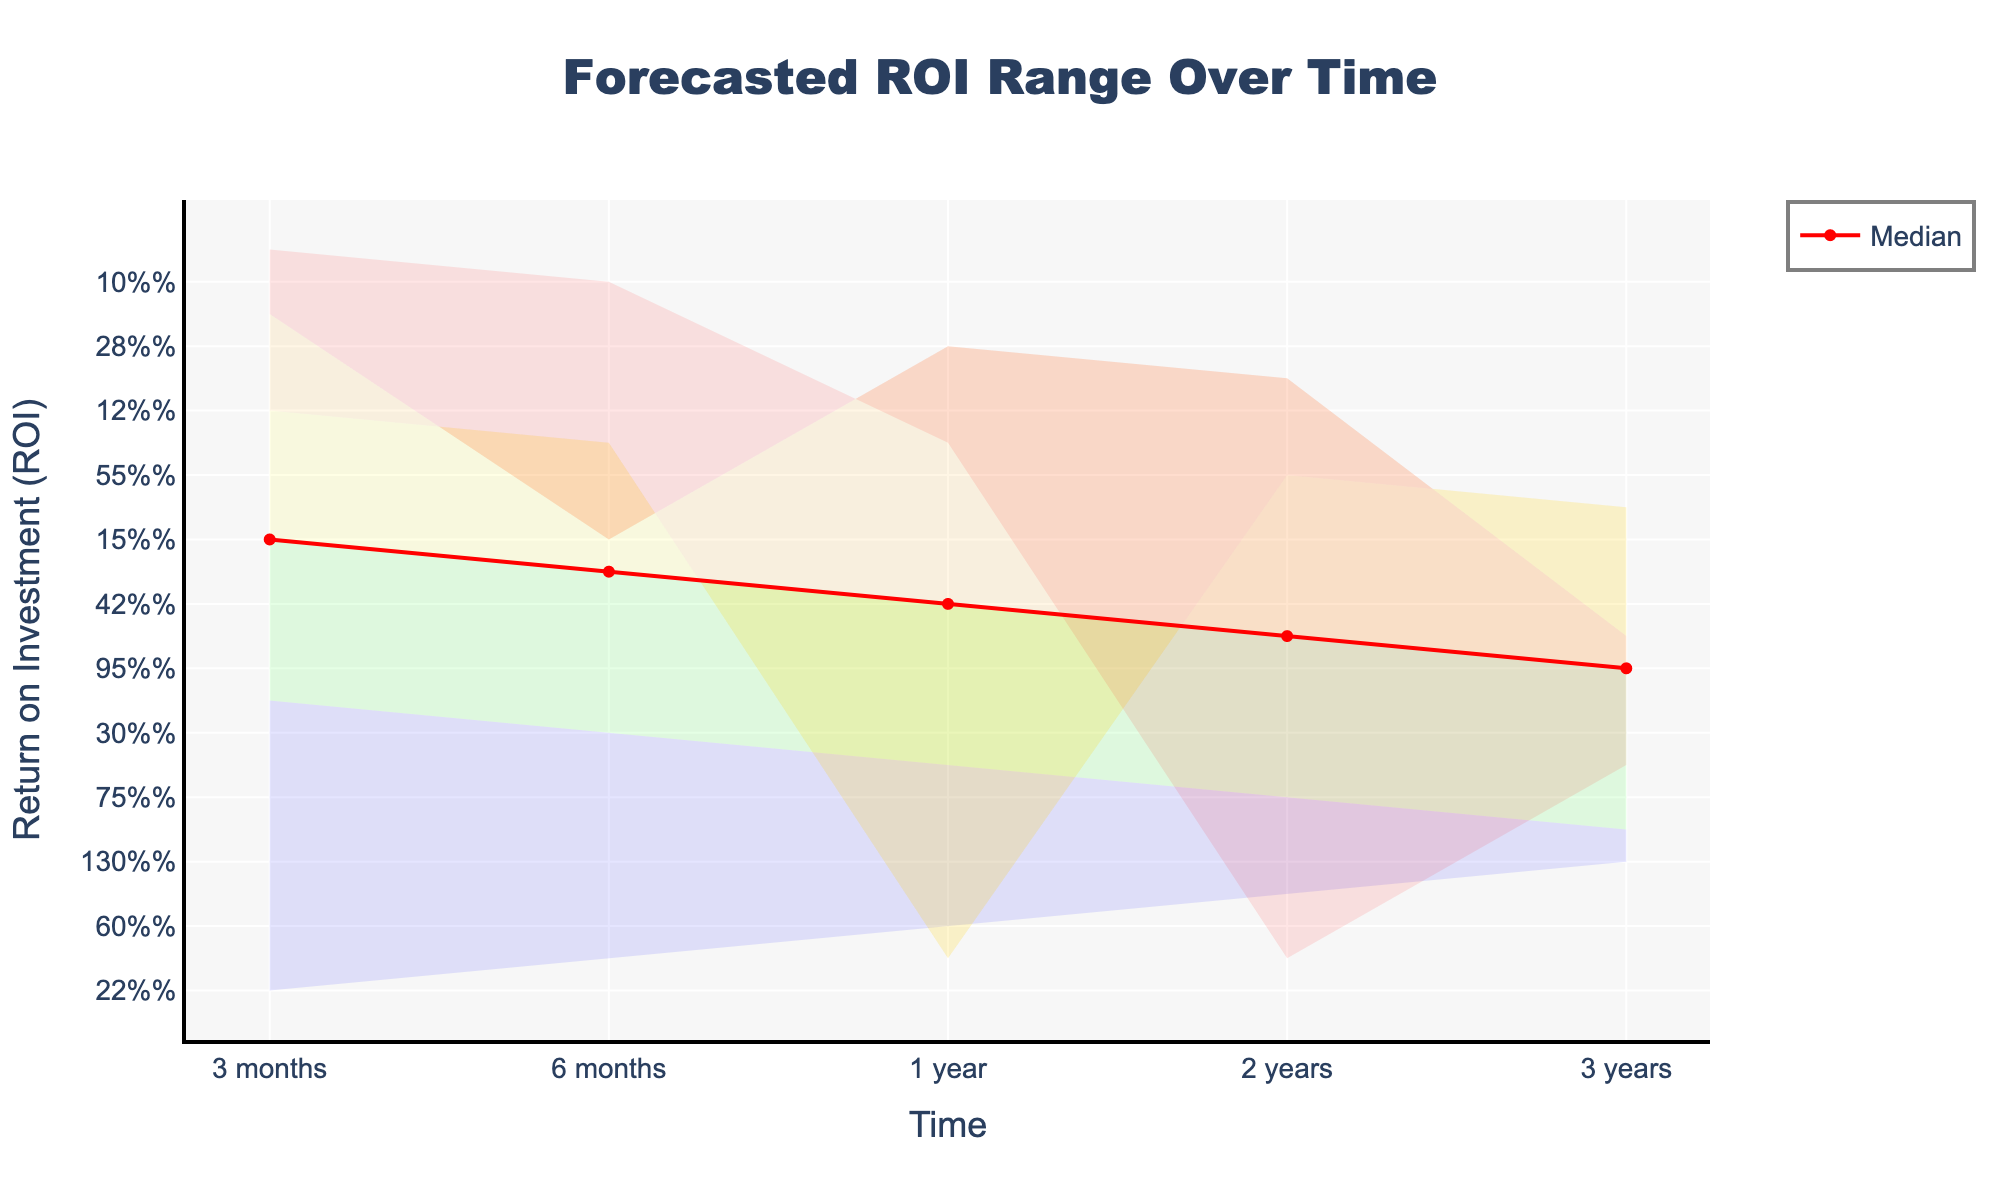What is the title of the chart? The title is found at the top of the chart and provides a summary of what the chart is about.
Answer: Forecasted ROI Range Over Time What is the ROI range for the 60th percentile after 1 year? Look at the point on the x-axis labeled "1 year" and check the value on the y-axis for the 60th percentile.
Answer: 42% What are the predicted upper and lower bounds of ROI after 3 years? The values for the upper and lower bounds are specified on the y-axis at the point labeled "3 years" on the x-axis.
Answer: 130% and 50% How does the median ROI change from 6 months to 1 year? Identify the median ROI (60th percentile) values at "6 months" and "1 year" on the x-axis, then calculate the difference.
Answer: It increases by 22% (42% - 20%) Which time period shows the highest ROI increase in the 40th percentile? Compare the ROI values at the 40th percentile across all time periods and identify the highest increase.
Answer: The highest increase is from 2 years to 3 years, which is 25% (80% - 55%) What is the color used to represent the area between the 60th and 80th percentiles? Identify the color used in the chart to fill the area between these two percentiles.
Answer: Green What is the range of ROI for the 20th percentile from 3 months to 3 years? Look at the 20th percentile values at "3 months" and "3 years" on the x-axis to find the range.
Answer: 8% to 65% How do the upper bounds of ROI after 6 months and 1 year compare? Check the upper bound values for the points "6 months" and "1 year" on the x-axis and compare them.
Answer: The upper bound after 1 year (60%) is higher than after 6 months (35%) What trend can be observed in the 80th percentile from 3 months to 3 years? Analyze the values of the 80th percentile at different time periods to understand the overall trend.
Answer: The 80th percentile generally increases over time What is the percentage increase in the lower bound ROI from 2 years to 3 years? Check the lower bound values for "2 years" and "3 years" on the x-axis and calculate the percentage increase.
Answer: 15% increase (50% - 35%) 